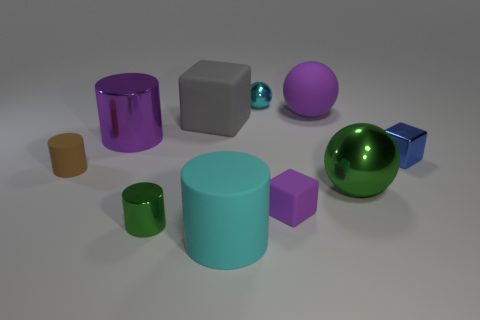Subtract all large matte spheres. How many spheres are left? 2 Subtract all brown cylinders. How many cylinders are left? 3 Subtract all red blocks. How many purple cylinders are left? 1 Add 9 cyan metallic balls. How many cyan metallic balls are left? 10 Add 8 green matte cylinders. How many green matte cylinders exist? 8 Subtract 1 green spheres. How many objects are left? 9 Subtract all cubes. How many objects are left? 7 Subtract 1 cylinders. How many cylinders are left? 3 Subtract all red cylinders. Subtract all purple spheres. How many cylinders are left? 4 Subtract all gray matte cubes. Subtract all brown cylinders. How many objects are left? 8 